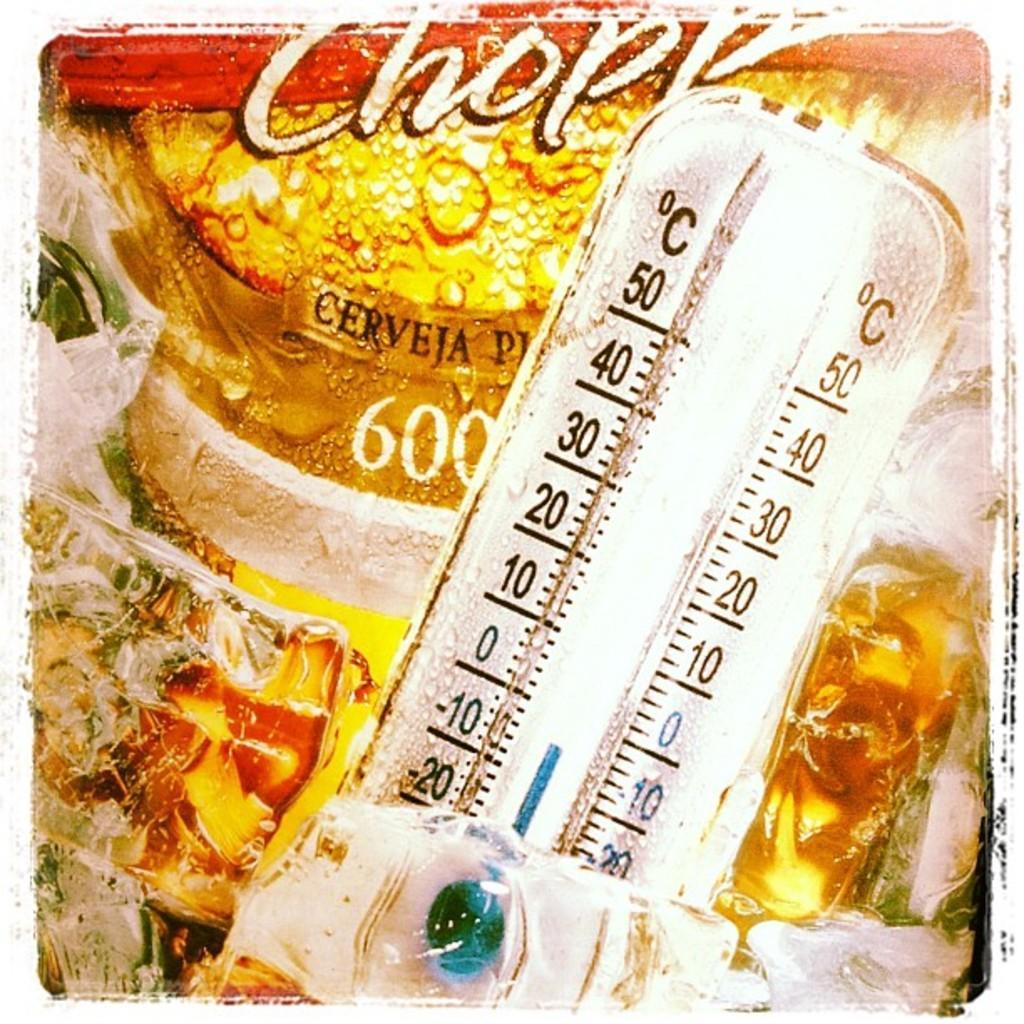Please provide a concise description of this image. In this image there is a temperature meter which is in the front and behind the temperature meter there is a paper cover with some text written on it. 